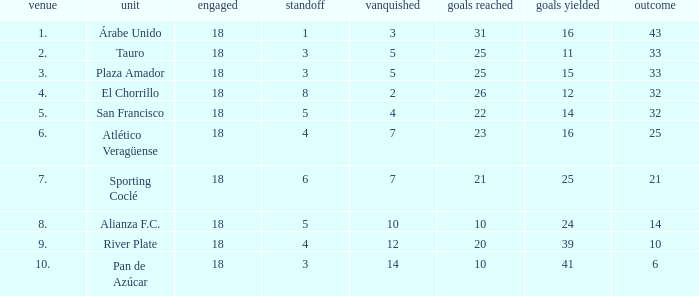How many goals were conceded by teams with 32 points, more than 2 losses and more than 22 goals scored? 0.0. 